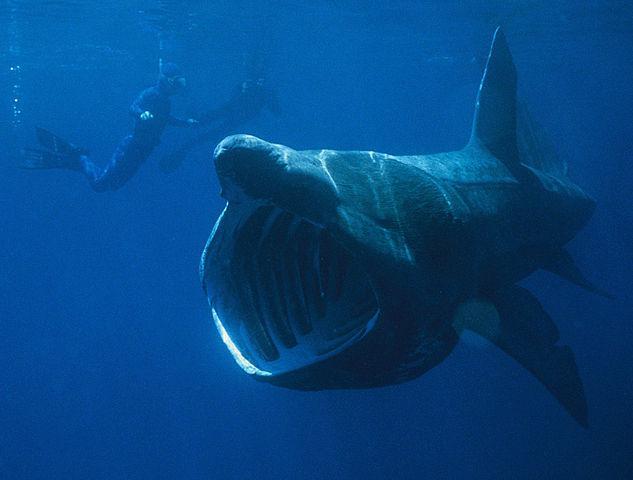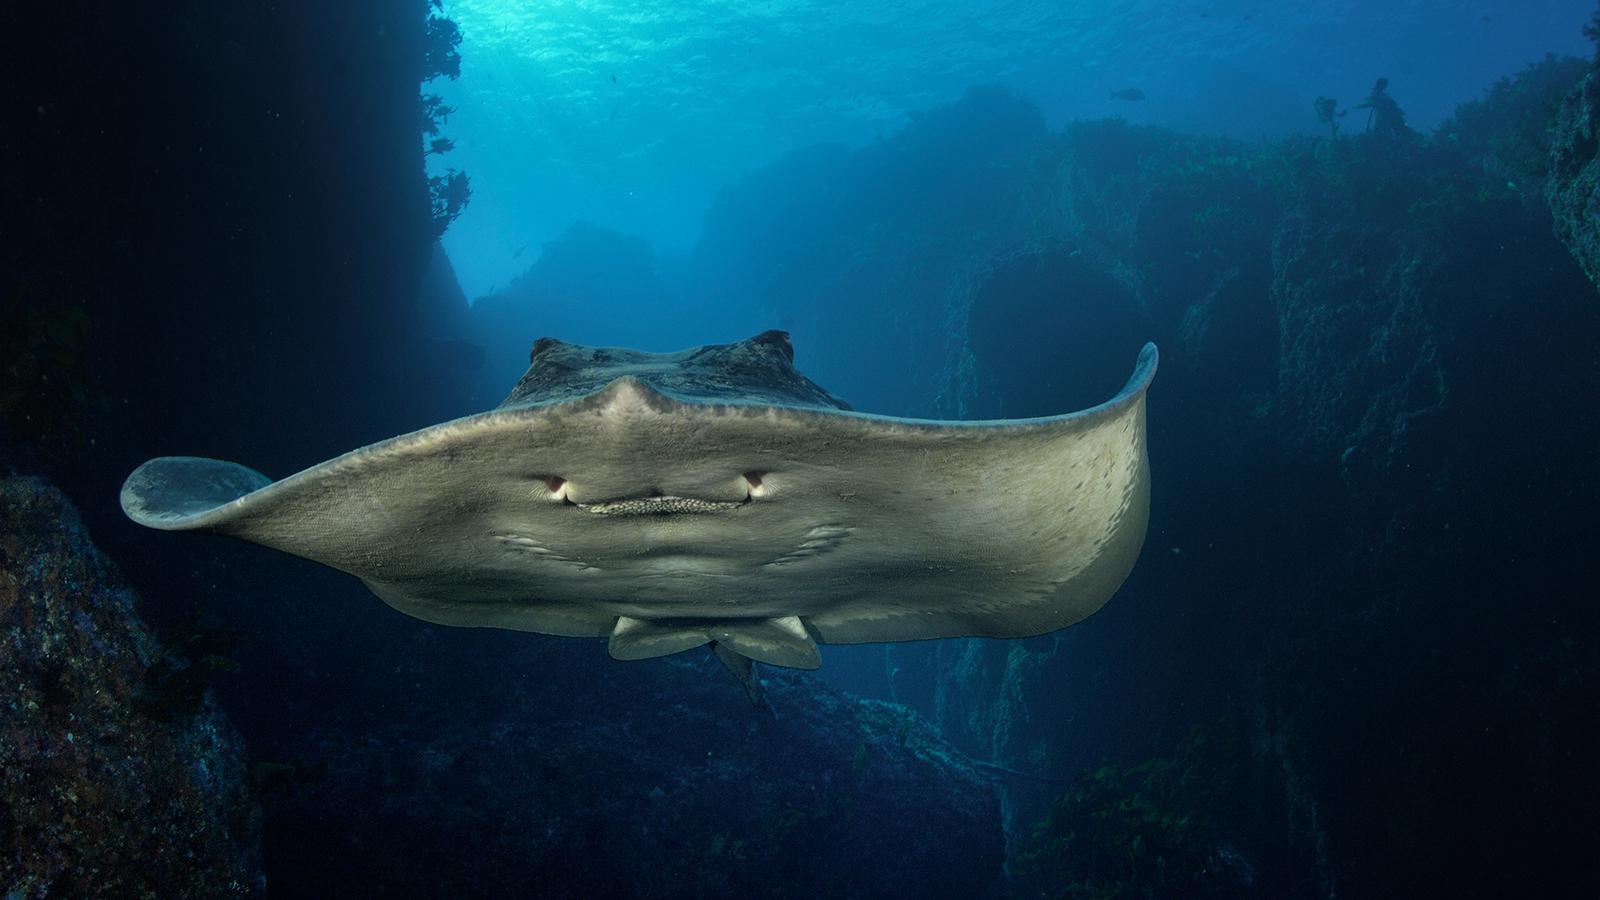The first image is the image on the left, the second image is the image on the right. Given the left and right images, does the statement "The bottom of the manta ray is visible in one of the images." hold true? Answer yes or no. Yes. 